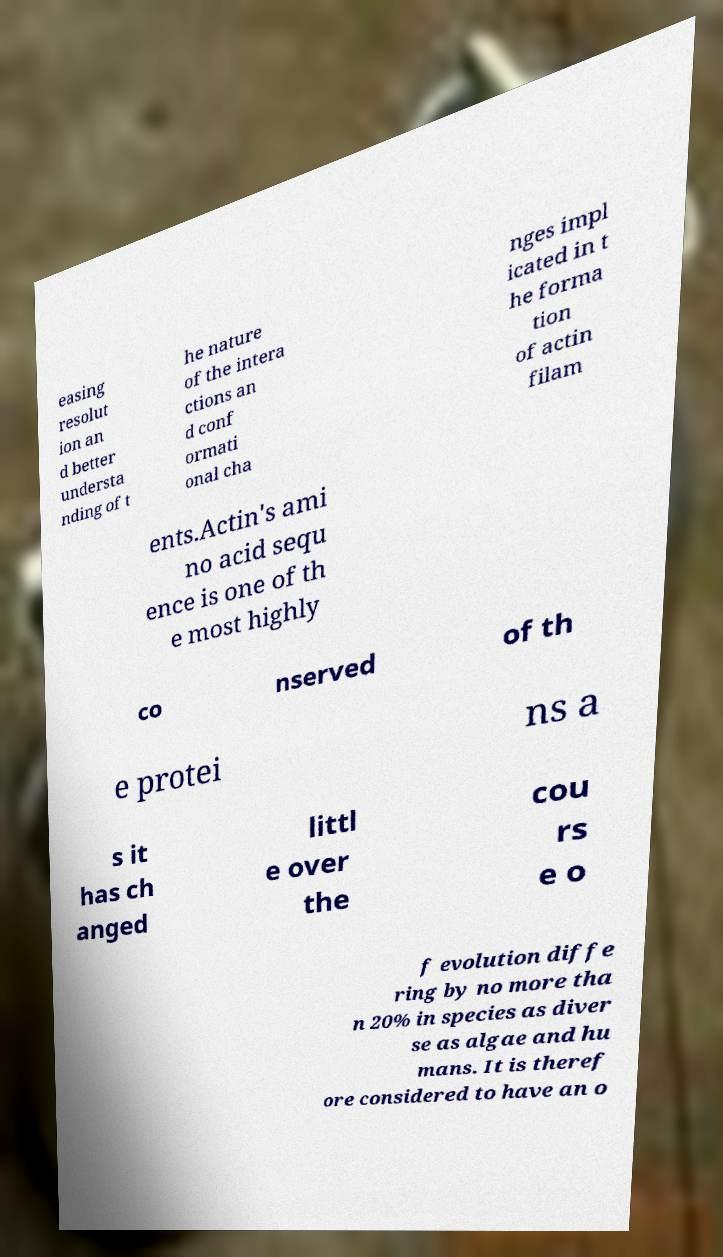What messages or text are displayed in this image? I need them in a readable, typed format. easing resolut ion an d better understa nding of t he nature of the intera ctions an d conf ormati onal cha nges impl icated in t he forma tion of actin filam ents.Actin's ami no acid sequ ence is one of th e most highly co nserved of th e protei ns a s it has ch anged littl e over the cou rs e o f evolution diffe ring by no more tha n 20% in species as diver se as algae and hu mans. It is theref ore considered to have an o 